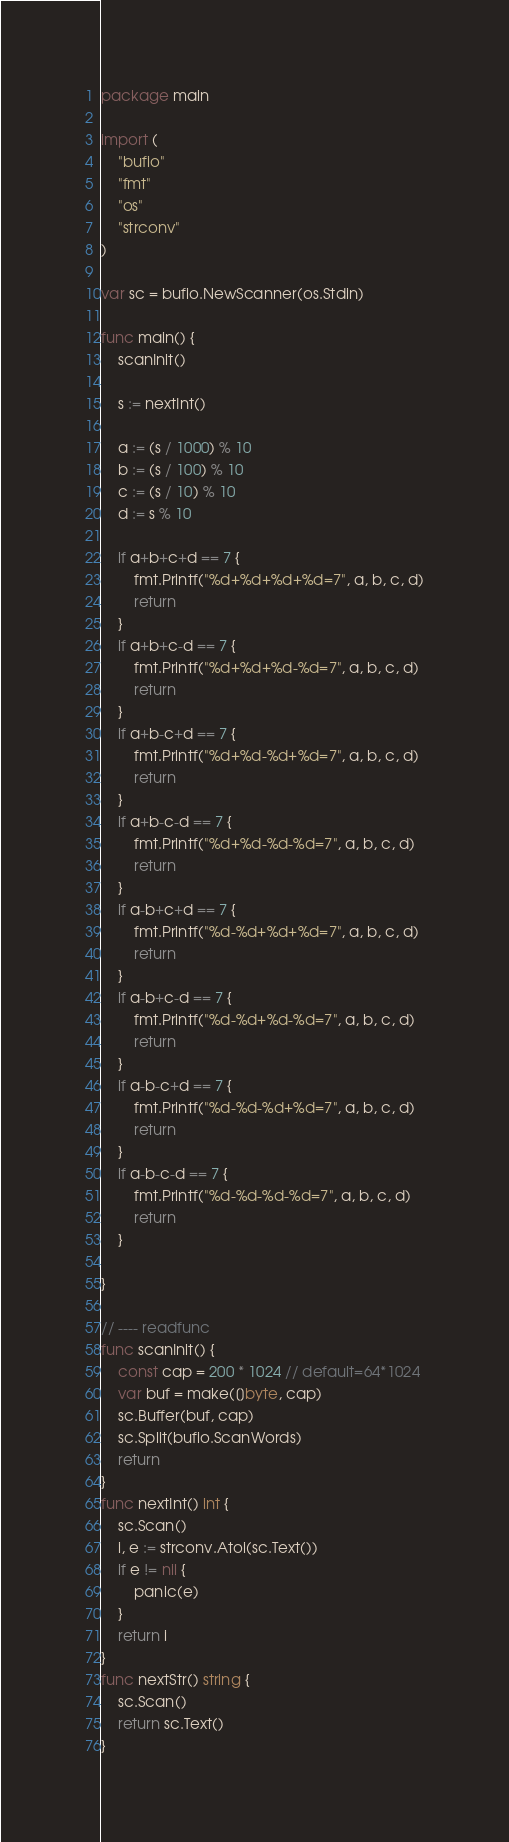<code> <loc_0><loc_0><loc_500><loc_500><_Go_>package main

import (
	"bufio"
	"fmt"
	"os"
	"strconv"
)

var sc = bufio.NewScanner(os.Stdin)

func main() {
	scanInit()

	s := nextInt()

	a := (s / 1000) % 10
	b := (s / 100) % 10
	c := (s / 10) % 10
	d := s % 10

	if a+b+c+d == 7 {
		fmt.Printf("%d+%d+%d+%d=7", a, b, c, d)
		return
	}
	if a+b+c-d == 7 {
		fmt.Printf("%d+%d+%d-%d=7", a, b, c, d)
		return
	}
	if a+b-c+d == 7 {
		fmt.Printf("%d+%d-%d+%d=7", a, b, c, d)
		return
	}
	if a+b-c-d == 7 {
		fmt.Printf("%d+%d-%d-%d=7", a, b, c, d)
		return
	}
	if a-b+c+d == 7 {
		fmt.Printf("%d-%d+%d+%d=7", a, b, c, d)
		return
	}
	if a-b+c-d == 7 {
		fmt.Printf("%d-%d+%d-%d=7", a, b, c, d)
		return
	}
	if a-b-c+d == 7 {
		fmt.Printf("%d-%d-%d+%d=7", a, b, c, d)
		return
	}
	if a-b-c-d == 7 {
		fmt.Printf("%d-%d-%d-%d=7", a, b, c, d)
		return
	}

}

// ---- readfunc
func scanInit() {
	const cap = 200 * 1024 // default=64*1024
	var buf = make([]byte, cap)
	sc.Buffer(buf, cap)
	sc.Split(bufio.ScanWords)
	return
}
func nextInt() int {
	sc.Scan()
	i, e := strconv.Atoi(sc.Text())
	if e != nil {
		panic(e)
	}
	return i
}
func nextStr() string {
	sc.Scan()
	return sc.Text()
}
</code> 